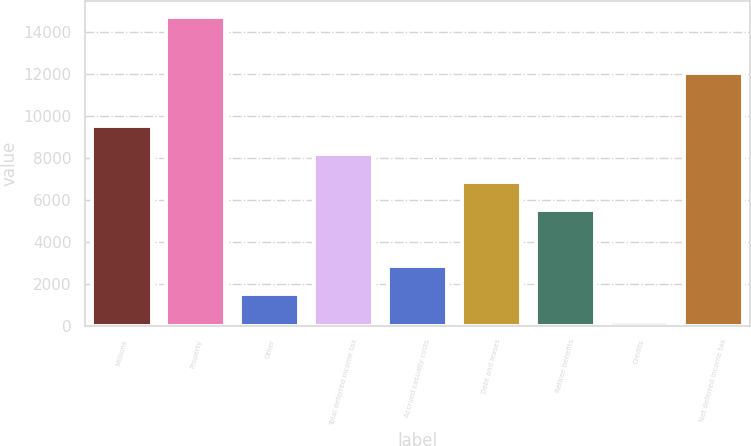Convert chart to OTSL. <chart><loc_0><loc_0><loc_500><loc_500><bar_chart><fcel>Millions<fcel>Property<fcel>Other<fcel>Total deferred income tax<fcel>Accrued casualty costs<fcel>Debt and leases<fcel>Retiree benefits<fcel>Credits<fcel>Net deferred income tax<nl><fcel>9522.4<fcel>14726.4<fcel>1529.2<fcel>8190.2<fcel>2861.4<fcel>6858<fcel>5525.8<fcel>197<fcel>12062<nl></chart> 